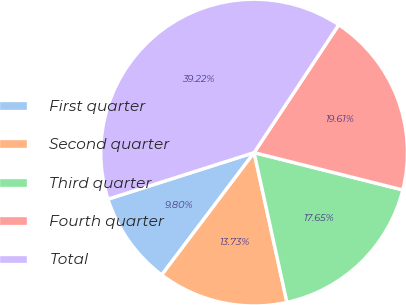Convert chart. <chart><loc_0><loc_0><loc_500><loc_500><pie_chart><fcel>First quarter<fcel>Second quarter<fcel>Third quarter<fcel>Fourth quarter<fcel>Total<nl><fcel>9.8%<fcel>13.73%<fcel>17.65%<fcel>19.61%<fcel>39.22%<nl></chart> 